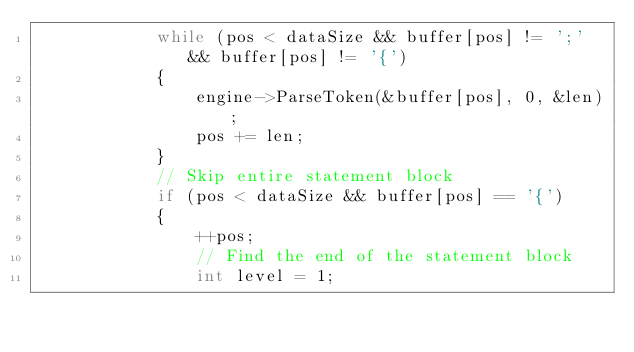Convert code to text. <code><loc_0><loc_0><loc_500><loc_500><_C++_>            while (pos < dataSize && buffer[pos] != ';' && buffer[pos] != '{')
            {
                engine->ParseToken(&buffer[pos], 0, &len);
                pos += len;
            }
            // Skip entire statement block
            if (pos < dataSize && buffer[pos] == '{')
            {
                ++pos;
                // Find the end of the statement block
                int level = 1;</code> 